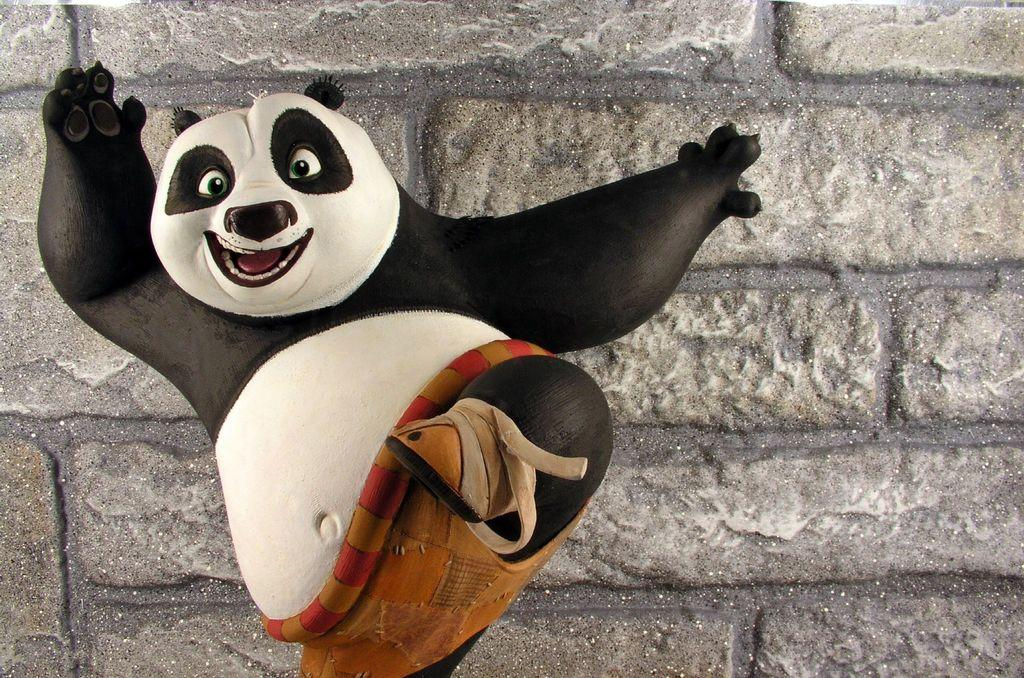What is located on the left side of the image? There is a statue of an animal on the left side of the image. What can be seen in the background of the image? There is a brick wall in the background of the image. What type of berry is being whipped by the animal in the image? There is no berry or whipping action depicted in the image; it features a statue of an animal and a brick wall in the background. 